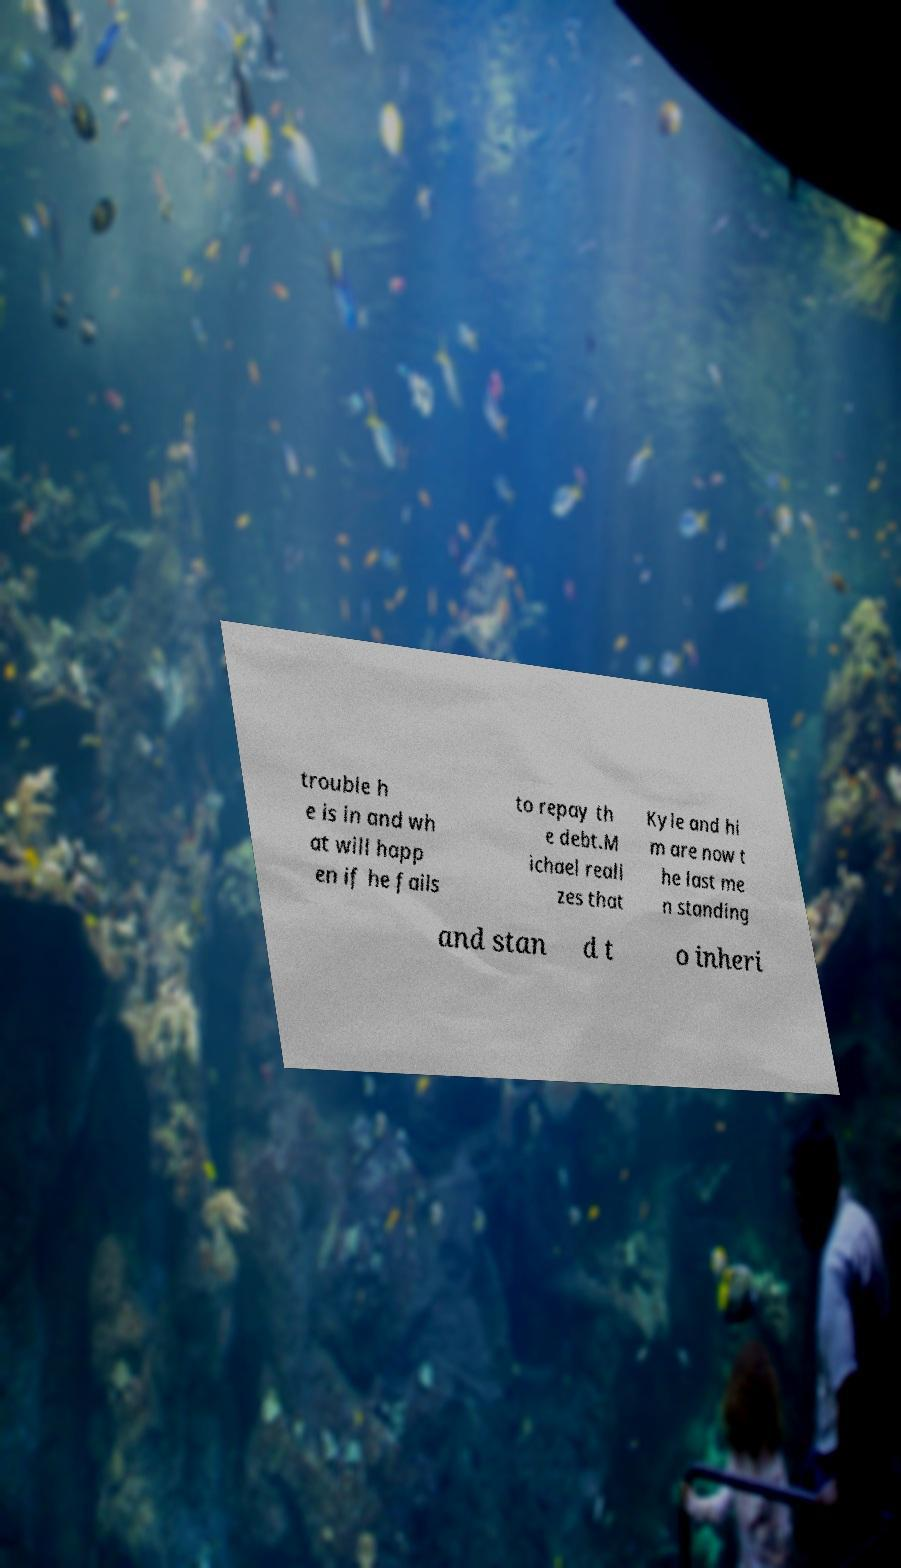Please read and relay the text visible in this image. What does it say? trouble h e is in and wh at will happ en if he fails to repay th e debt.M ichael reali zes that Kyle and hi m are now t he last me n standing and stan d t o inheri 